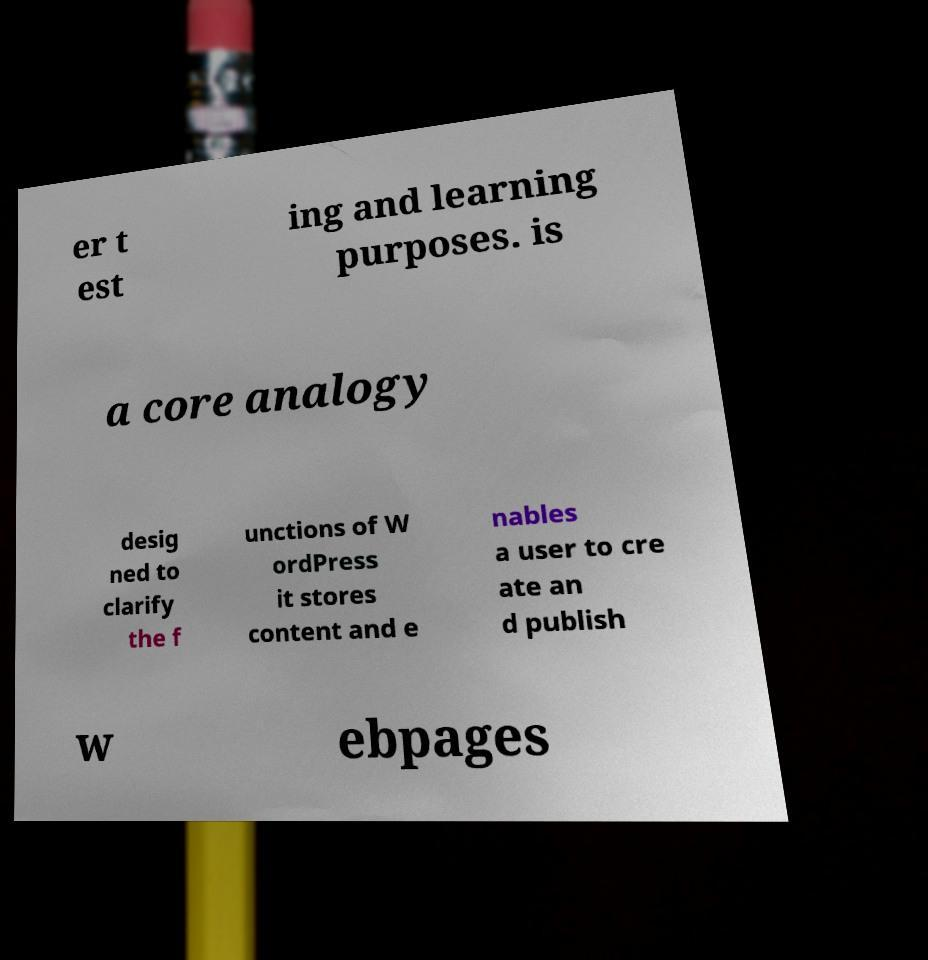There's text embedded in this image that I need extracted. Can you transcribe it verbatim? er t est ing and learning purposes. is a core analogy desig ned to clarify the f unctions of W ordPress it stores content and e nables a user to cre ate an d publish w ebpages 